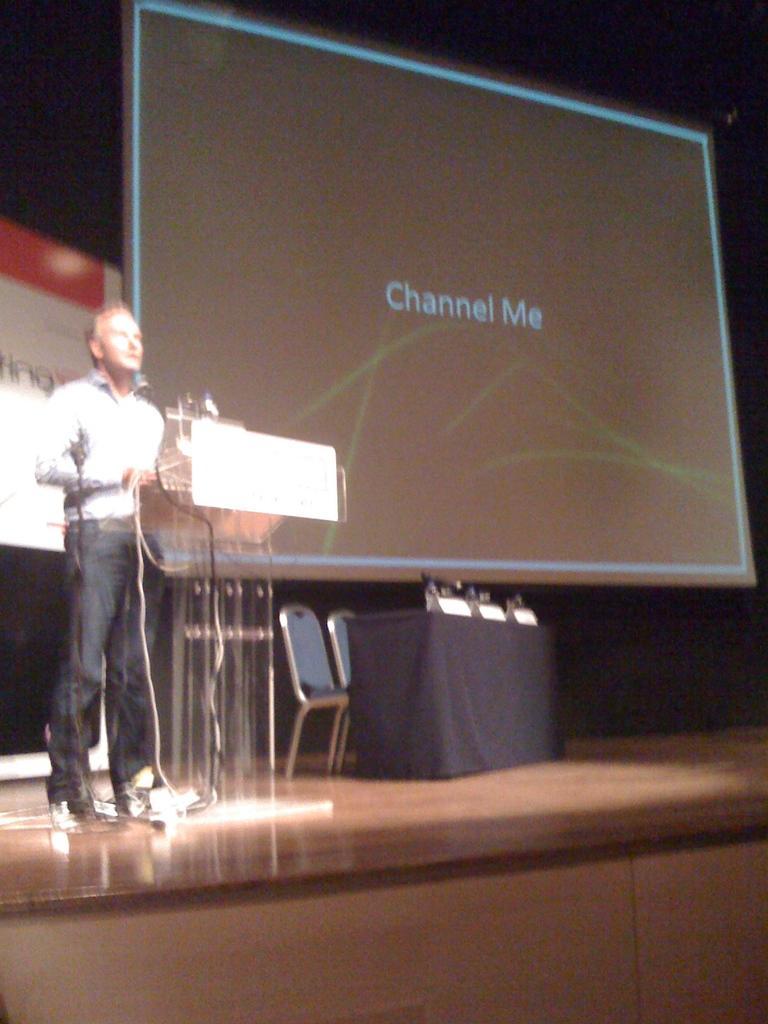Could you give a brief overview of what you see in this image? In this image there is a person on the stage in front of the podium. In the background screen is visible. Image also consists of two chairs and a table covered with black cloth. 